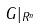<formula> <loc_0><loc_0><loc_500><loc_500>G | _ { R ^ { n } }</formula> 